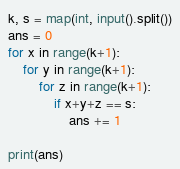<code> <loc_0><loc_0><loc_500><loc_500><_Python_>k, s = map(int, input().split())
ans = 0
for x in range(k+1):
    for y in range(k+1):
        for z in range(k+1):
            if x+y+z == s:
                ans += 1

print(ans)</code> 